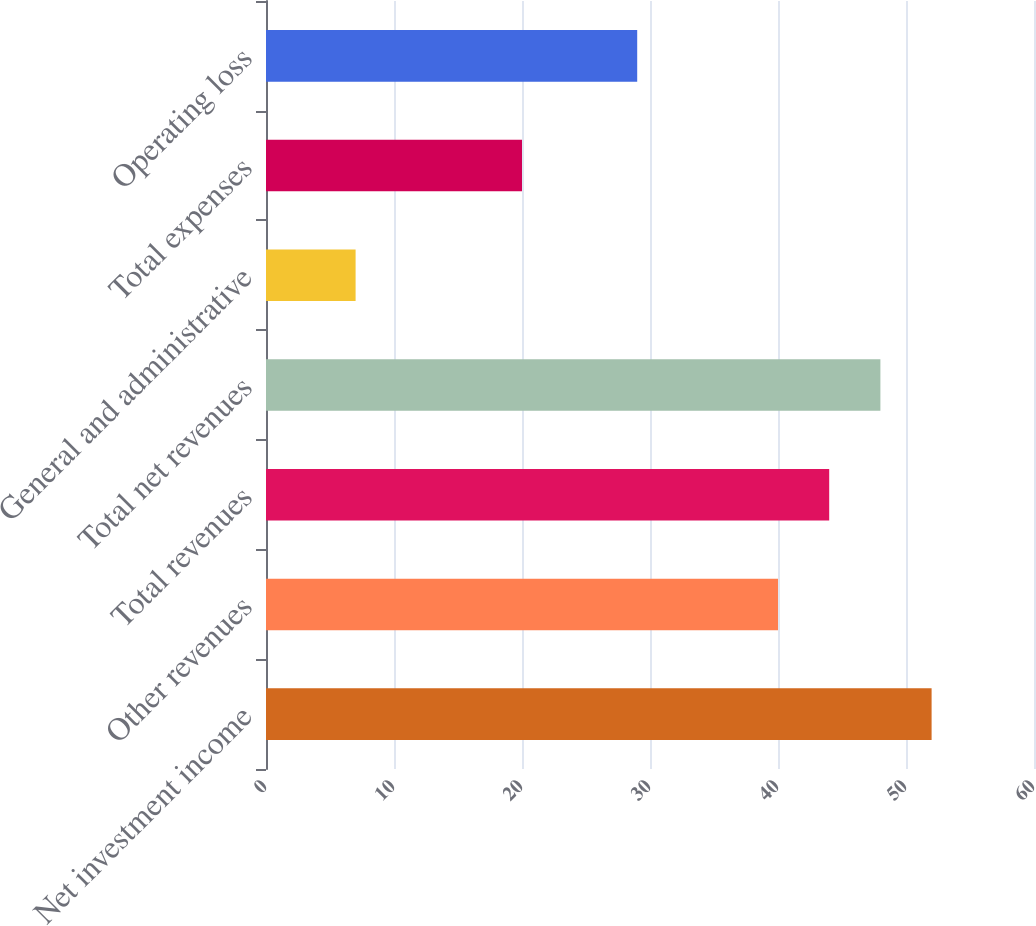Convert chart. <chart><loc_0><loc_0><loc_500><loc_500><bar_chart><fcel>Net investment income<fcel>Other revenues<fcel>Total revenues<fcel>Total net revenues<fcel>General and administrative<fcel>Total expenses<fcel>Operating loss<nl><fcel>52<fcel>40<fcel>44<fcel>48<fcel>7<fcel>20<fcel>29<nl></chart> 